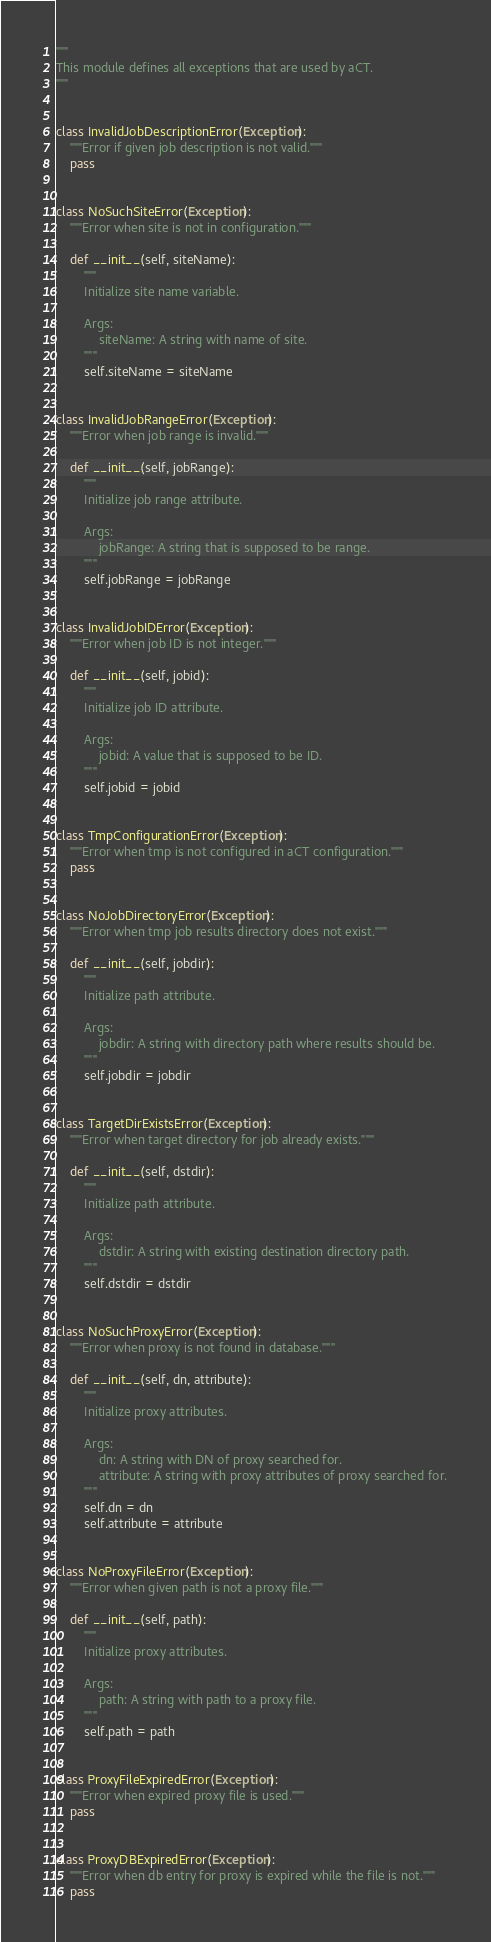Convert code to text. <code><loc_0><loc_0><loc_500><loc_500><_Python_>"""
This module defines all exceptions that are used by aCT.
"""


class InvalidJobDescriptionError(Exception):
    """Error if given job description is not valid."""
    pass


class NoSuchSiteError(Exception):
    """Error when site is not in configuration."""

    def __init__(self, siteName):
        """
        Initialize site name variable.

        Args:
            siteName: A string with name of site.
        """
        self.siteName = siteName


class InvalidJobRangeError(Exception):
    """Error when job range is invalid."""

    def __init__(self, jobRange):
        """
        Initialize job range attribute.

        Args:
            jobRange: A string that is supposed to be range.
        """
        self.jobRange = jobRange


class InvalidJobIDError(Exception):
    """Error when job ID is not integer."""

    def __init__(self, jobid):
        """
        Initialize job ID attribute.

        Args:
            jobid: A value that is supposed to be ID.
        """
        self.jobid = jobid


class TmpConfigurationError(Exception):
    """Error when tmp is not configured in aCT configuration."""
    pass


class NoJobDirectoryError(Exception):
    """Error when tmp job results directory does not exist."""

    def __init__(self, jobdir):
        """
        Initialize path attribute.

        Args:
            jobdir: A string with directory path where results should be.
        """
        self.jobdir = jobdir


class TargetDirExistsError(Exception):
    """Error when target directory for job already exists."""

    def __init__(self, dstdir):
        """
        Initialize path attribute.

        Args:
            dstdir: A string with existing destination directory path.
        """
        self.dstdir = dstdir


class NoSuchProxyError(Exception):
    """Error when proxy is not found in database."""

    def __init__(self, dn, attribute):
        """
        Initialize proxy attributes.

        Args:
            dn: A string with DN of proxy searched for.
            attribute: A string with proxy attributes of proxy searched for.
        """
        self.dn = dn
        self.attribute = attribute


class NoProxyFileError(Exception):
    """Error when given path is not a proxy file."""

    def __init__(self, path):
        """
        Initialize proxy attributes.

        Args:
            path: A string with path to a proxy file.
        """
        self.path = path


class ProxyFileExpiredError(Exception):
    """Error when expired proxy file is used."""
    pass


class ProxyDBExpiredError(Exception):
    """Error when db entry for proxy is expired while the file is not."""
    pass


</code> 